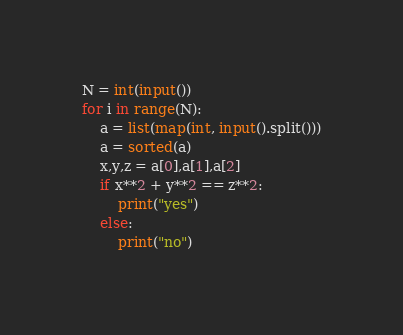<code> <loc_0><loc_0><loc_500><loc_500><_Python_>N = int(input())
for i in range(N):
    a = list(map(int, input().split()))
    a = sorted(a)
    x,y,z = a[0],a[1],a[2]
    if x**2 + y**2 == z**2:
        print("yes")
    else:
        print("no")</code> 